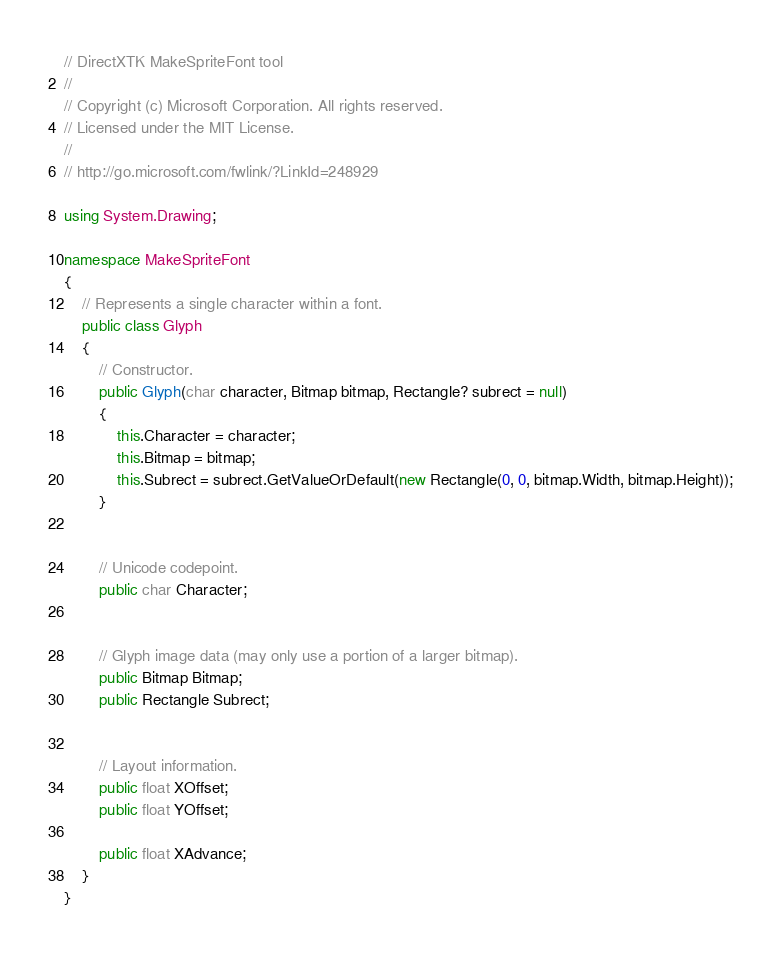<code> <loc_0><loc_0><loc_500><loc_500><_C#_>// DirectXTK MakeSpriteFont tool
//
// Copyright (c) Microsoft Corporation. All rights reserved.
// Licensed under the MIT License.
//
// http://go.microsoft.com/fwlink/?LinkId=248929

using System.Drawing;

namespace MakeSpriteFont
{
    // Represents a single character within a font.
    public class Glyph
    {
        // Constructor.
        public Glyph(char character, Bitmap bitmap, Rectangle? subrect = null)
        {
            this.Character = character;
            this.Bitmap = bitmap;
            this.Subrect = subrect.GetValueOrDefault(new Rectangle(0, 0, bitmap.Width, bitmap.Height));
        }


        // Unicode codepoint.
        public char Character;


        // Glyph image data (may only use a portion of a larger bitmap).
        public Bitmap Bitmap;
        public Rectangle Subrect;
        

        // Layout information.
        public float XOffset;
        public float YOffset;

        public float XAdvance;
    }
}
</code> 